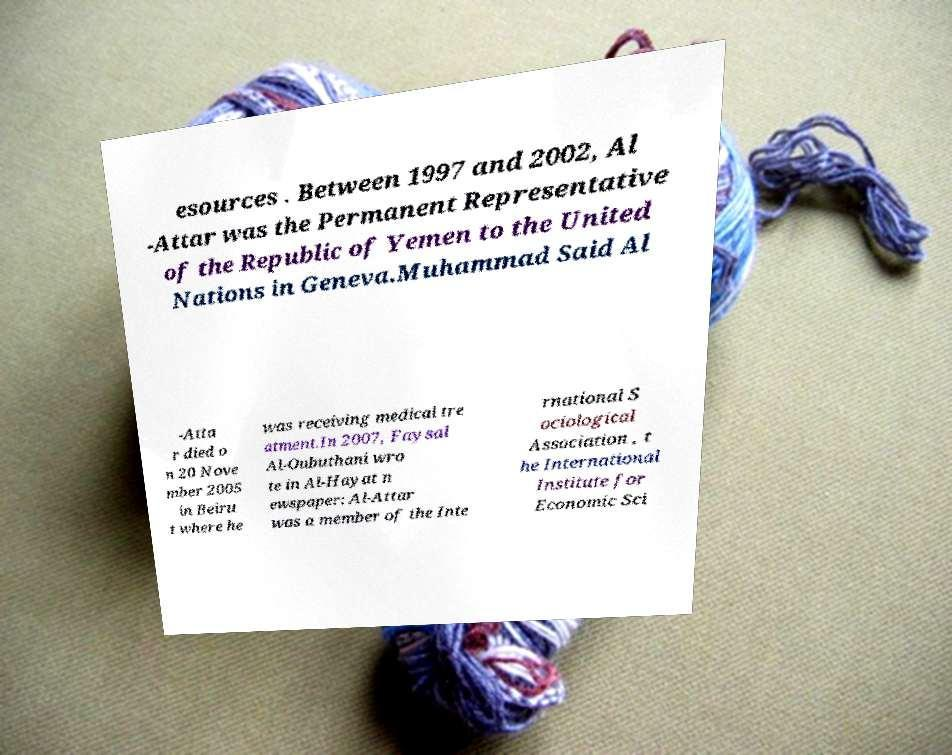There's text embedded in this image that I need extracted. Can you transcribe it verbatim? esources . Between 1997 and 2002, Al -Attar was the Permanent Representative of the Republic of Yemen to the United Nations in Geneva.Muhammad Said Al -Atta r died o n 20 Nove mber 2005 in Beiru t where he was receiving medical tre atment.In 2007, Faysal Al-Oubuthani wro te in Al-Hayat n ewspaper: Al-Attar was a member of the Inte rnational S ociological Association , t he International Institute for Economic Sci 